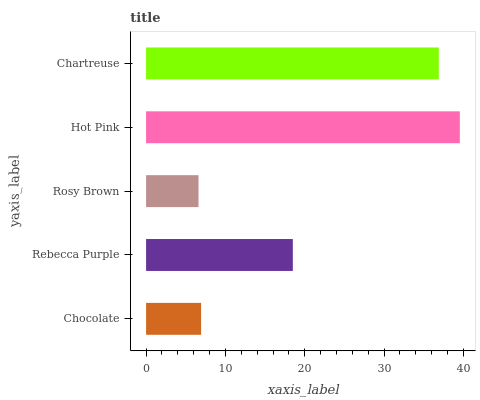Is Rosy Brown the minimum?
Answer yes or no. Yes. Is Hot Pink the maximum?
Answer yes or no. Yes. Is Rebecca Purple the minimum?
Answer yes or no. No. Is Rebecca Purple the maximum?
Answer yes or no. No. Is Rebecca Purple greater than Chocolate?
Answer yes or no. Yes. Is Chocolate less than Rebecca Purple?
Answer yes or no. Yes. Is Chocolate greater than Rebecca Purple?
Answer yes or no. No. Is Rebecca Purple less than Chocolate?
Answer yes or no. No. Is Rebecca Purple the high median?
Answer yes or no. Yes. Is Rebecca Purple the low median?
Answer yes or no. Yes. Is Hot Pink the high median?
Answer yes or no. No. Is Hot Pink the low median?
Answer yes or no. No. 